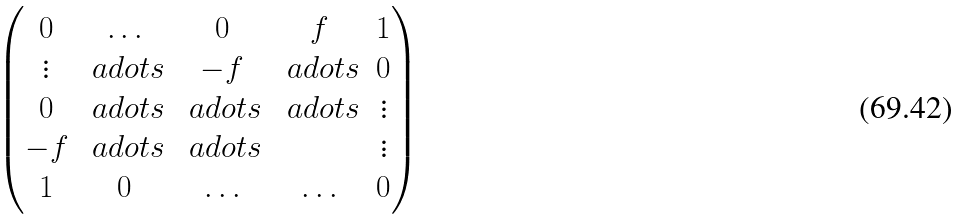<formula> <loc_0><loc_0><loc_500><loc_500>\begin{pmatrix} 0 & \hdots & 0 & f & 1 \\ \vdots & \ a d o t s & - f & \ a d o t s & 0 \\ 0 & \ a d o t s & \ a d o t s & \ a d o t s & \vdots \\ - f & \ a d o t s & \ a d o t s & & \vdots \\ 1 & 0 & \hdots & \hdots & 0 \end{pmatrix}</formula> 